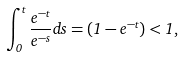<formula> <loc_0><loc_0><loc_500><loc_500>\int _ { 0 } ^ { t } \frac { e ^ { - t } } { e ^ { - s } } d s = ( 1 - e ^ { - t } ) < 1 ,</formula> 